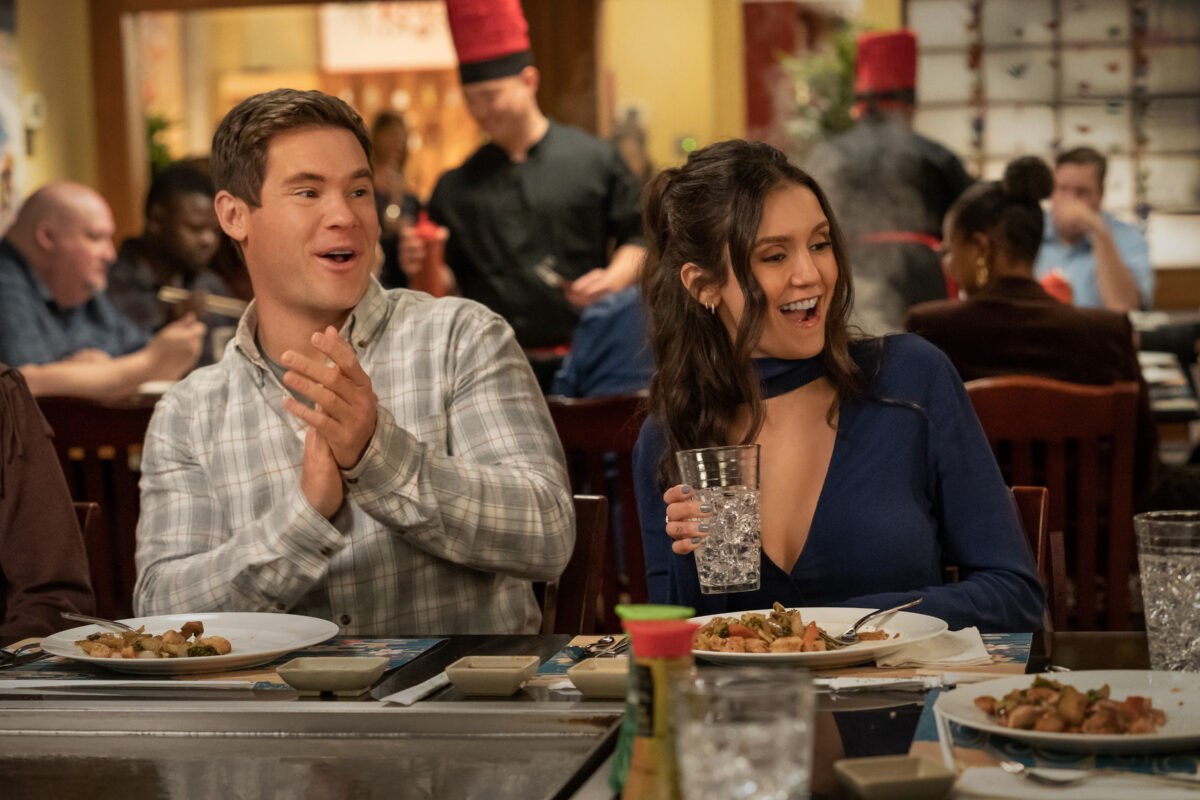Can you elaborate on the elements of the picture provided? In this bright and engaging moment from the movie 'Isn't It Romantic', actress Nina Dobrev is depicted wearing a stylish blue off-the-shoulder top. She is dining with actor Adam Devine, who is dressed in a neatly pressed gray suit. They appear to be sharing a joyful conversation at a restaurant, evident from their animated expressions and the wide grins on their faces. Adam's hands are enthusiastically clapping, further enhancing the lively ambiance. The table before them is filled with plates of delicious-looking food, suggesting they are enjoying a hearty meal. The background showcases a bustling restaurant environment, with other diners and staff moving about, adding depth and vibrancy to the scene. 